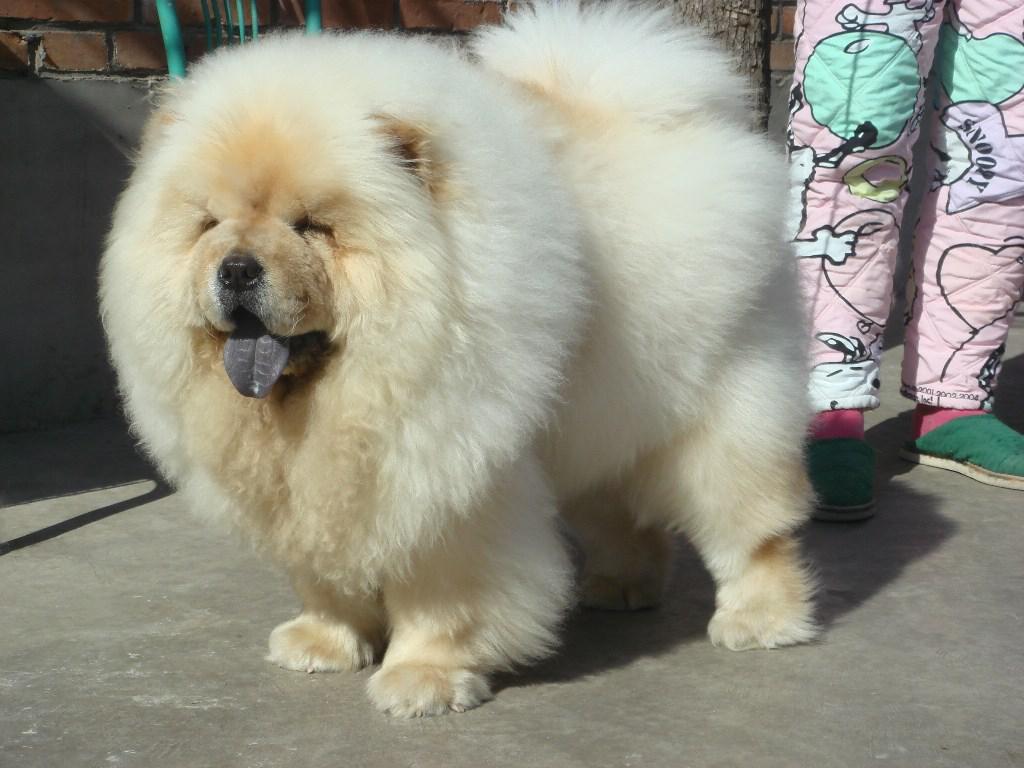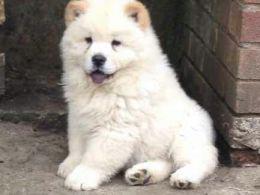The first image is the image on the left, the second image is the image on the right. Given the left and right images, does the statement "At least two dogs have their mouths open." hold true? Answer yes or no. Yes. 